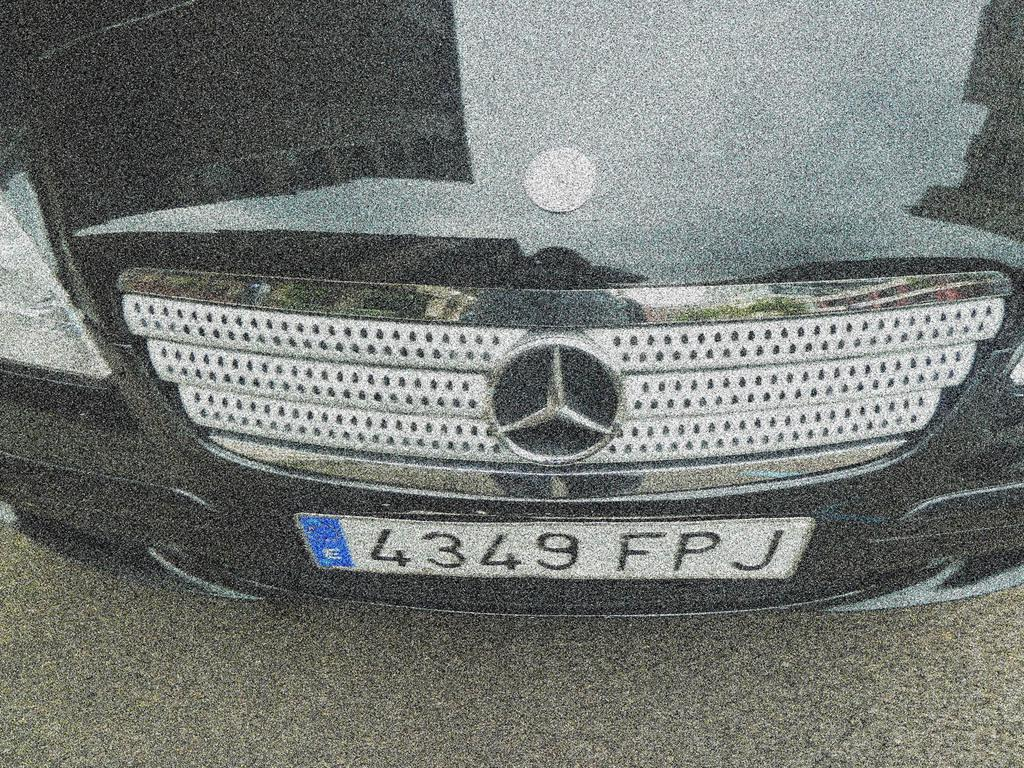What is the main subject of the image? There is a vehicle in the image. What can be seen on the vehicle? The number plate of the vehicle is visible. What else is present in the image besides the vehicle? There is a logo in the image. What type of surface is visible in the image? There is a road in the image. What type of haircut does the vehicle have in the image? There is no haircut present in the image, as it features a vehicle and not a person. 